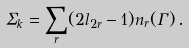Convert formula to latex. <formula><loc_0><loc_0><loc_500><loc_500>\Sigma _ { k } = \sum _ { r } ( 2 l _ { 2 r } - 1 ) n _ { r } ( \Gamma ) \, .</formula> 